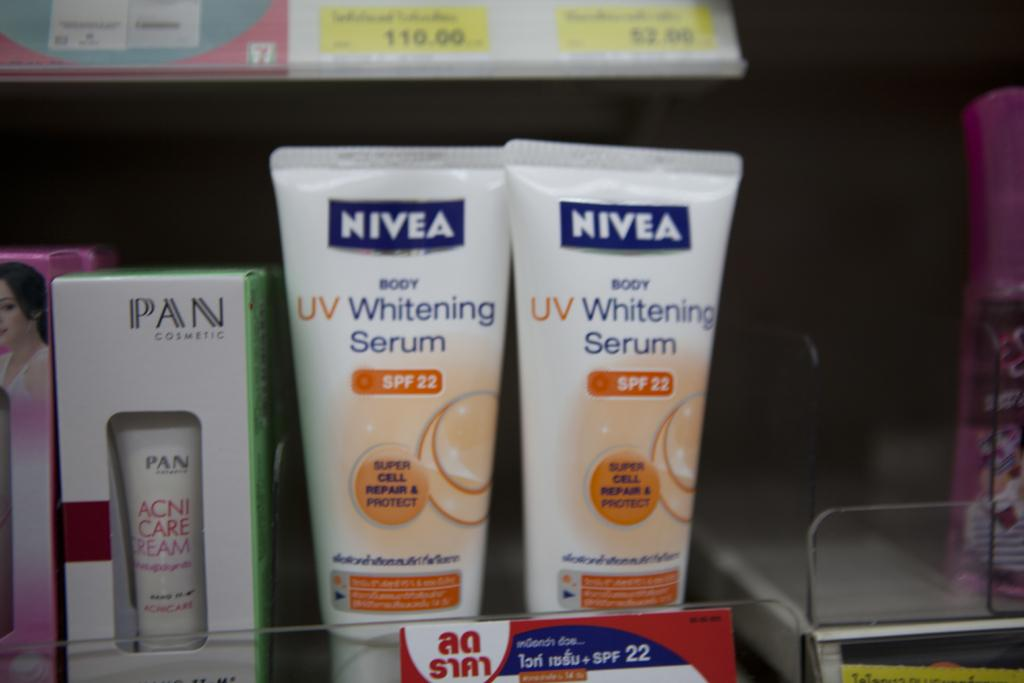<image>
Describe the image concisely. Two bottles of Nivea whitening serum stand next to an acne care product. 